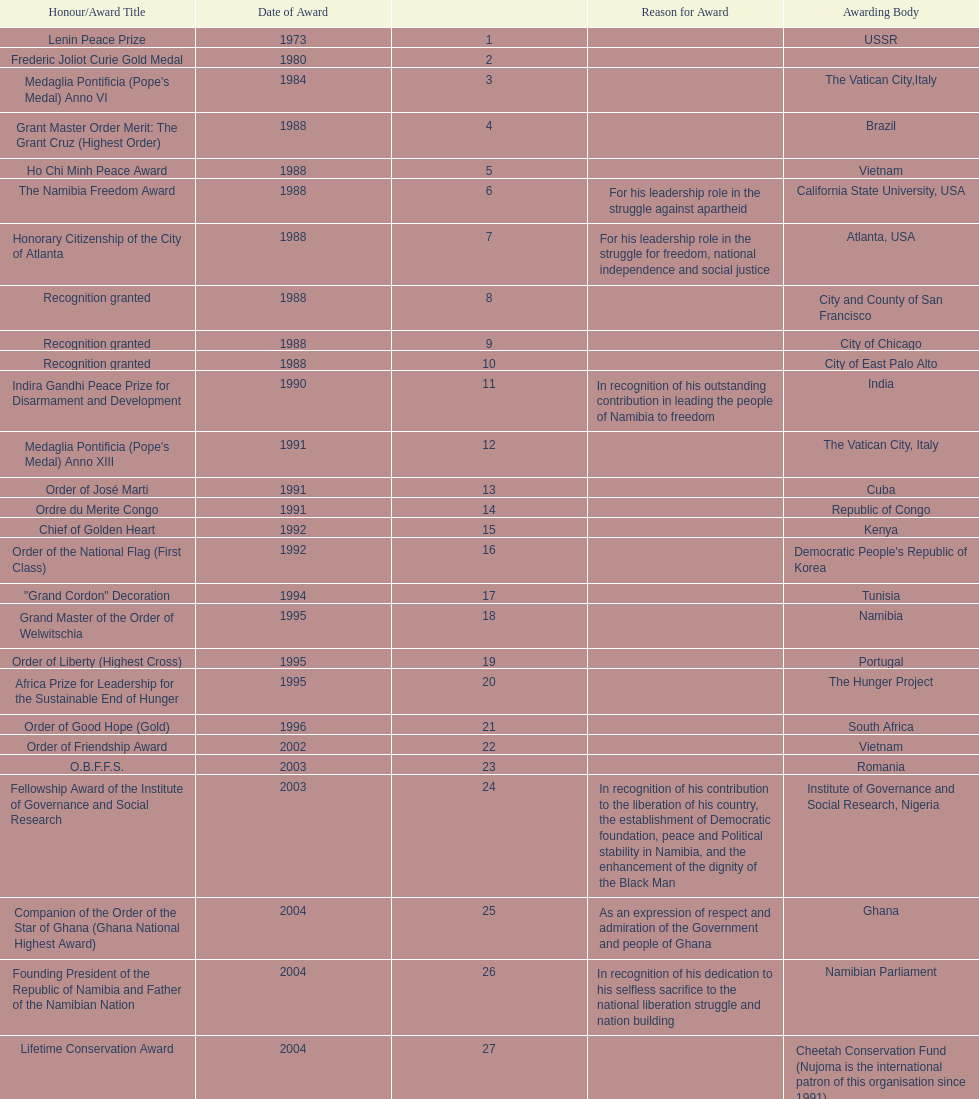Which award did nujoma win last? Sir Seretse Khama SADC Meda. 